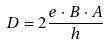<formula> <loc_0><loc_0><loc_500><loc_500>D = 2 \frac { e \cdot B \cdot A } { h }</formula> 